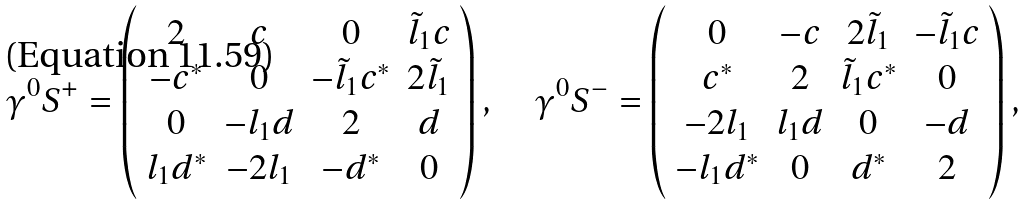<formula> <loc_0><loc_0><loc_500><loc_500>\gamma ^ { 0 } S ^ { + } = \left ( \begin{array} { c c c c } 2 & c & 0 & \tilde { l } _ { 1 } c \\ - c ^ { * } & 0 & - \tilde { l } _ { 1 } c ^ { * } & 2 \tilde { l } _ { 1 } \\ 0 & - l _ { 1 } d & 2 & d \\ l _ { 1 } d ^ { * } & - 2 l _ { 1 } & - d ^ { * } & 0 \end{array} \right ) , \quad \gamma ^ { 0 } S ^ { - } = \left ( \begin{array} { c c c c } 0 & - c & 2 \tilde { l } _ { 1 } & - \tilde { l } _ { 1 } c \\ c ^ { * } & 2 & \tilde { l } _ { 1 } c ^ { * } & 0 \\ - 2 l _ { 1 } & l _ { 1 } d & 0 & - d \\ - l _ { 1 } d ^ { * } & 0 & d ^ { * } & 2 \end{array} \right ) ,</formula> 